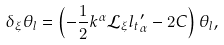Convert formula to latex. <formula><loc_0><loc_0><loc_500><loc_500>\delta _ { \xi } \theta _ { l } = \left ( - \frac { 1 } { 2 } k ^ { \alpha } \mathcal { L } _ { \xi } { l _ { t } } ^ { \prime } _ { \alpha } - 2 C \right ) \theta _ { l } ,</formula> 